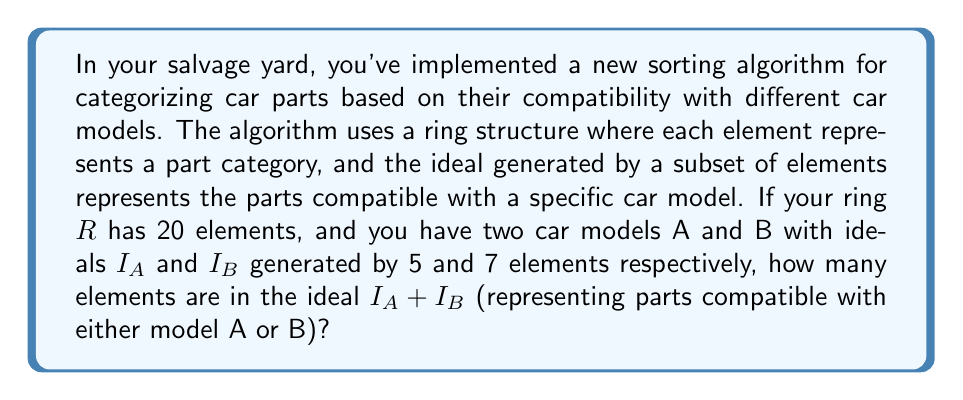Can you solve this math problem? To solve this problem, we need to apply concepts from ring theory and set theory:

1) First, recall that in a ring, an ideal generated by a subset of elements includes all linear combinations of those elements with ring coefficients.

2) The sum of two ideals, $I_A + I_B$, is the smallest ideal containing both $I_A$ and $I_B$. It consists of all elements of the form $a + b$ where $a \in I_A$ and $b \in I_B$.

3) To find the number of elements in $I_A + I_B$, we can use the inclusion-exclusion principle:

   $$|I_A + I_B| = |I_A| + |I_B| - |I_A \cap I_B|$$

4) In a ring with 20 elements, an ideal generated by 5 elements could potentially contain all 20 elements, depending on the ring's structure. Without more information about the specific ring, we'll assume the worst-case scenario where $|I_A| = 20$ and $|I_B| = 20$.

5) The intersection $I_A \cap I_B$ is also an ideal. In the worst-case scenario, it could be the entire ring (20 elements), and in the best-case scenario, it could be just the zero element (1 element).

6) Therefore, the number of elements in $I_A + I_B$ could range from 20 (if $I_A = I_B = R$) to 20 (if $I_A \cap I_B = \{0\}$).

Without more specific information about the ring structure, we can't determine the exact number of elements in $I_A + I_B$, but we know it's at most 20.
Answer: The ideal $I_A + I_B$ contains at most 20 elements. 